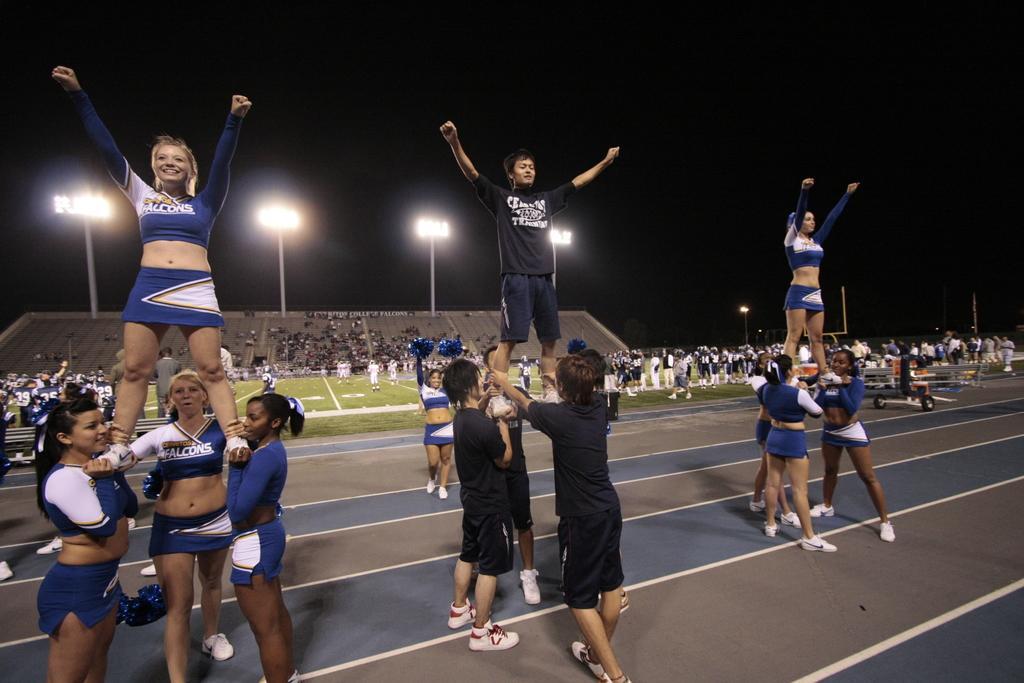Please provide a concise description of this image. In the picture we can see some cheer girls standing on the path on each other person and in the background, we can see some players are playing on the ground we and we can also see audience are sitting on the chairs and watching the match and we can also see a light to the pole and a sky in the dark. 